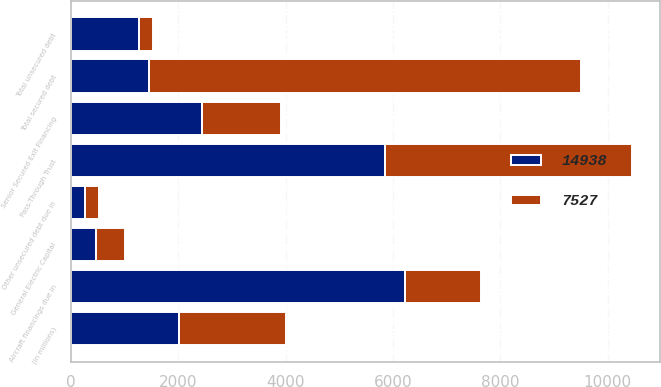<chart> <loc_0><loc_0><loc_500><loc_500><stacked_bar_chart><ecel><fcel>(in millions)<fcel>Senior Secured Exit Financing<fcel>General Electric Capital<fcel>Pass-Through Trust<fcel>Aircraft financings due in<fcel>Total secured debt<fcel>Other unsecured debt due in<fcel>Total unsecured debt<nl><fcel>14938<fcel>2008<fcel>2448<fcel>469<fcel>5844<fcel>6224<fcel>1463<fcel>265<fcel>1265<nl><fcel>7527<fcel>2007<fcel>1463<fcel>542<fcel>4615<fcel>1415<fcel>8035<fcel>266<fcel>266<nl></chart> 